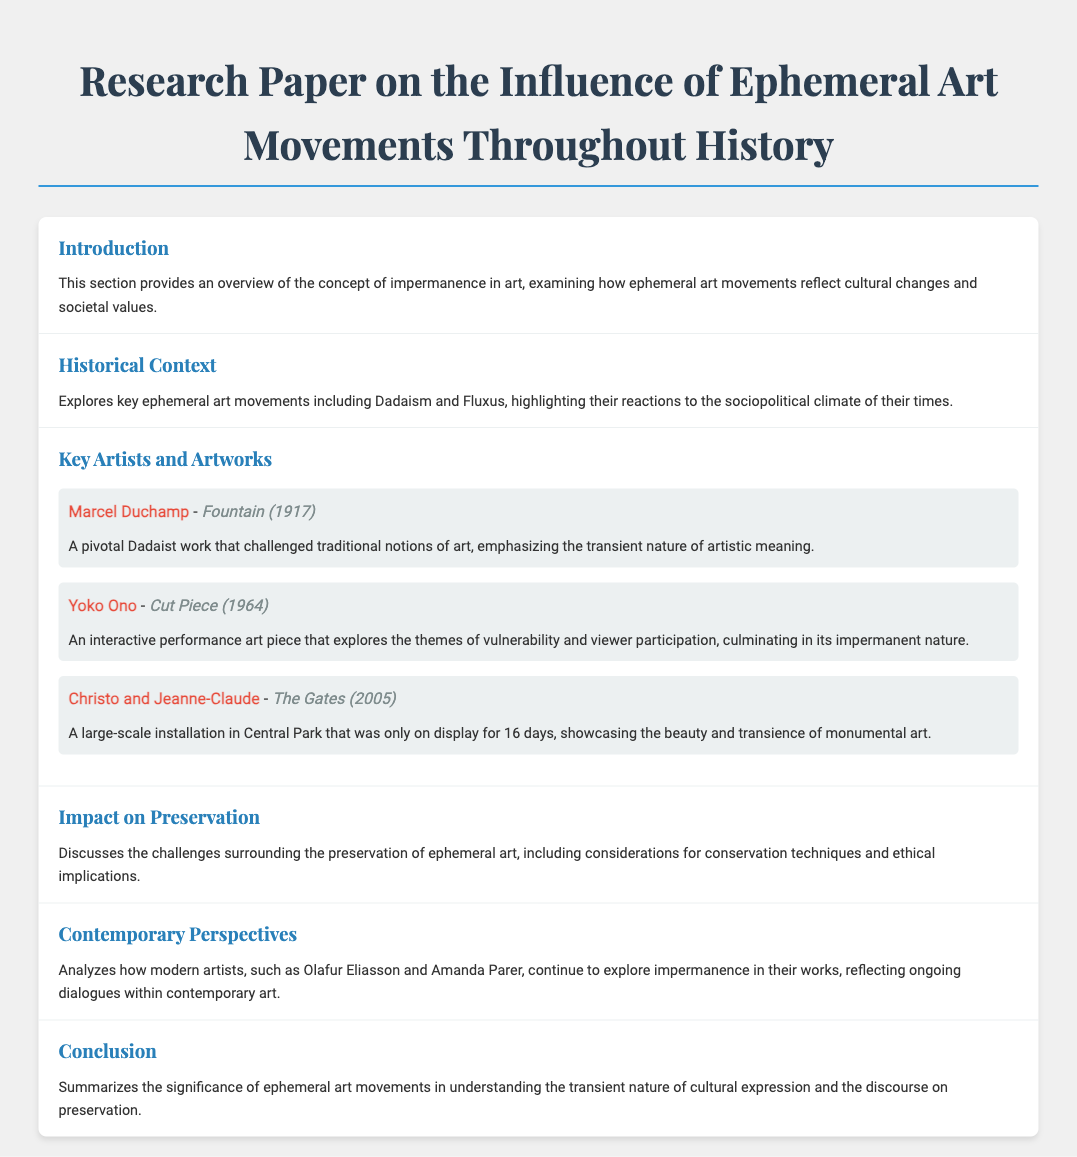What is the focus of the introduction? The introduction provides an overview of the concept of impermanence in art.
Answer: Overview of impermanence in art Which ephemeral art movement is highlighted in the historical context? The historical context explores key ephemeral art movements including Dadaism and Fluxus.
Answer: Dadaism and Fluxus Who created the artwork "Fountain"? Marcel Duchamp is the artist of the pivotal Dadaist work titled "Fountain."
Answer: Marcel Duchamp How long was "The Gates" on display? "The Gates" was on display for 16 days, showcasing its transience.
Answer: 16 days What performance piece by Yoko Ono involves viewer participation? The performance piece "Cut Piece" by Yoko Ono explores themes of vulnerability and viewer participation.
Answer: Cut Piece What do contemporary artists like Olafur Eliasson explore in their works? Modern artists such as Olafur Eliasson explore impermanence in their works.
Answer: Impermanence What is discussed in the impact on preservation section? The impact on preservation discusses challenges surrounding the preservation of ephemeral art.
Answer: Challenges of preservation Which section summarizes the significance of ephemeral art movements? The conclusion summarizes the significance of ephemeral art movements in understanding cultural expression and preservation.
Answer: Conclusion What key theme is analyzed in contemporary perspectives? The contemporary perspectives analyze ongoing dialogues within contemporary art regarding impermanence.
Answer: Ongoing dialogues on impermanence 